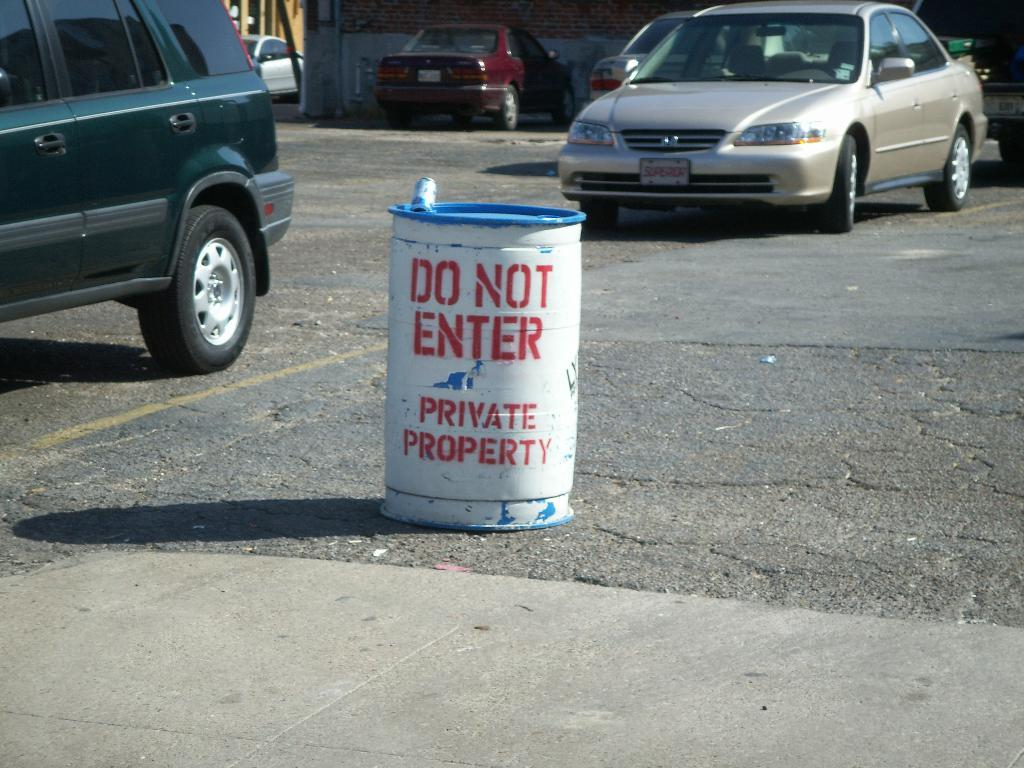Provide a one-sentence caption for the provided image. A white barrel in a parking lot has DO NOT ENTER spray painted in red stencil letters. 